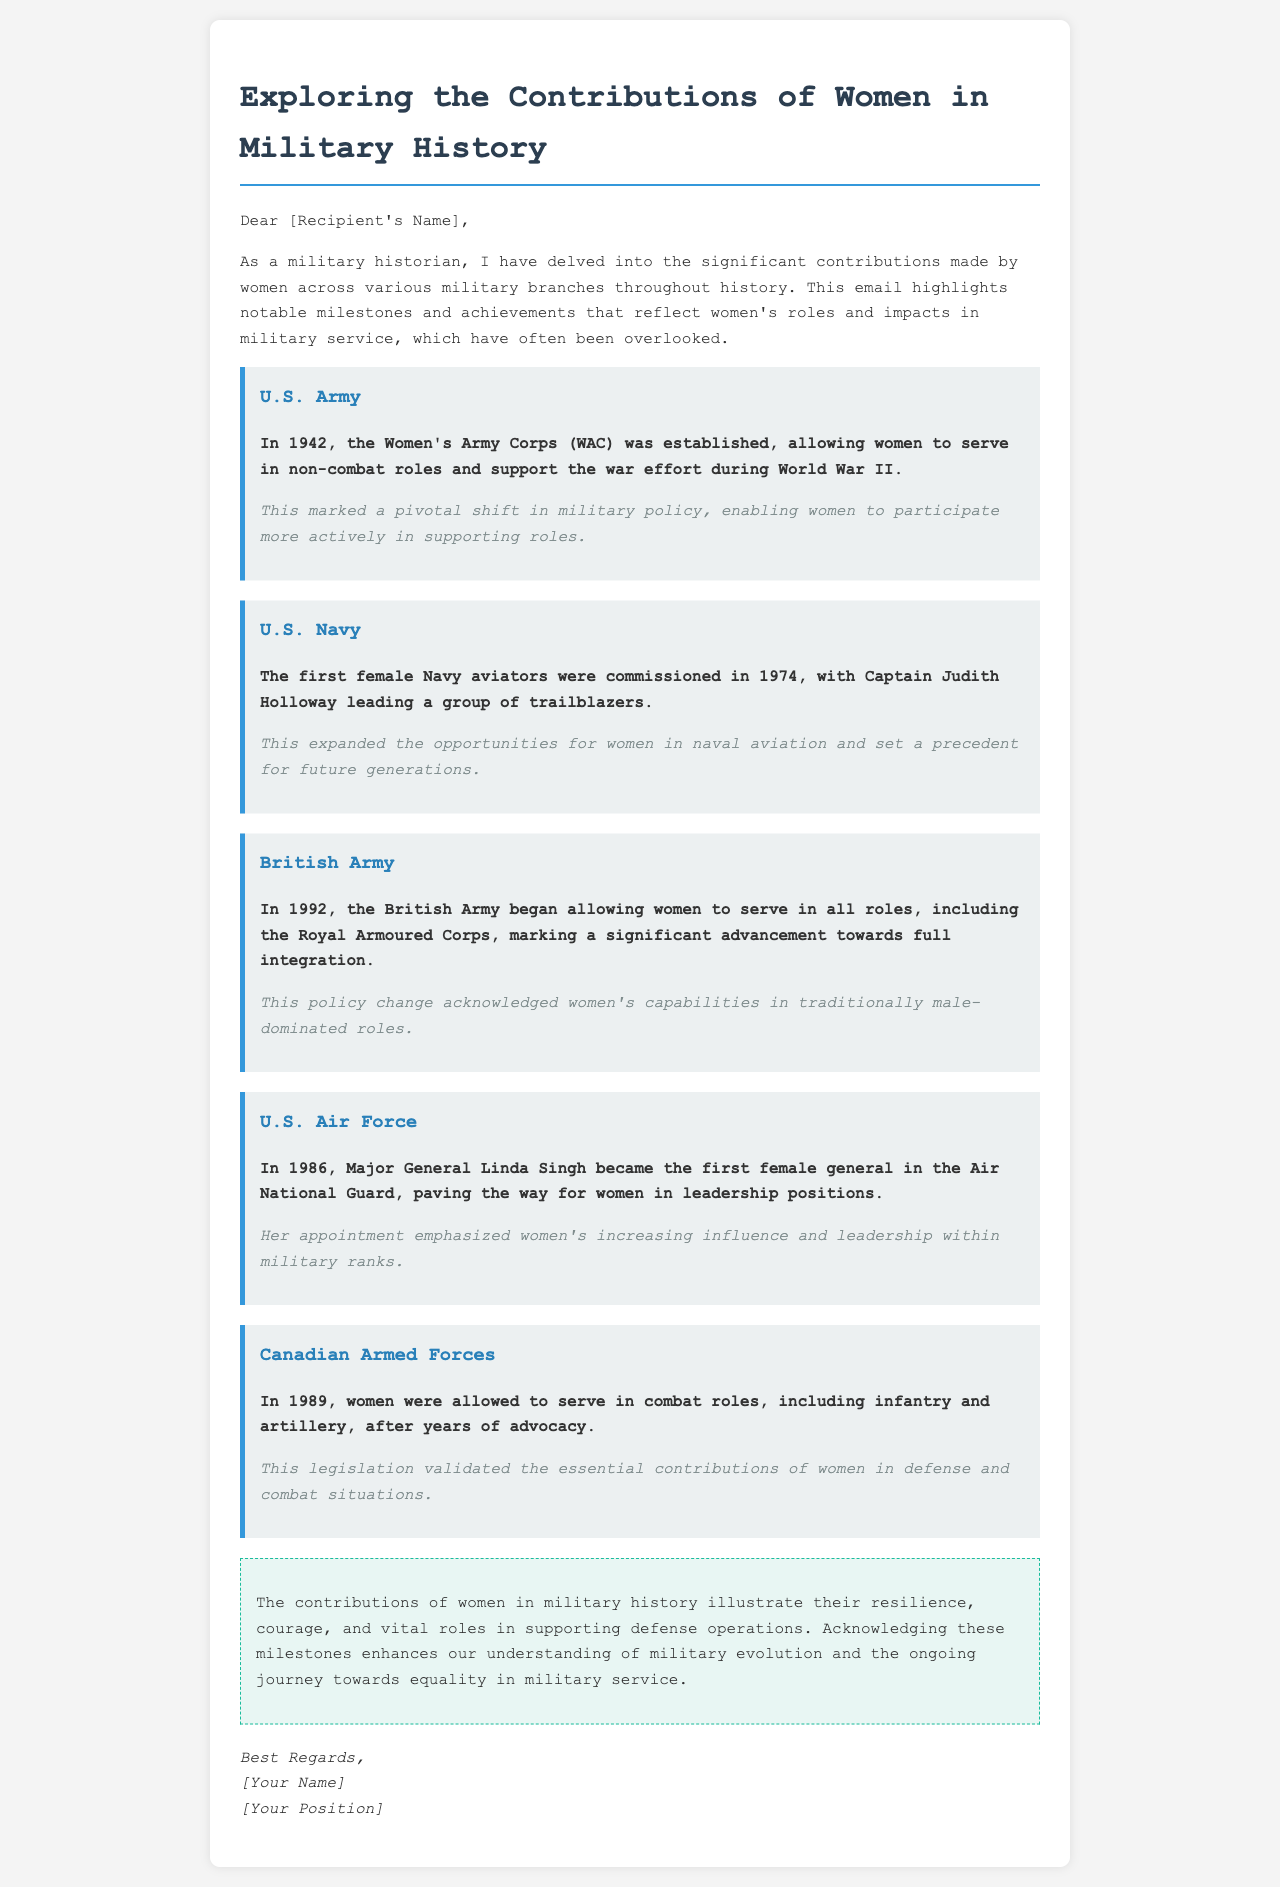what year was the Women's Army Corps established? The document states that the Women's Army Corps (WAC) was established in 1942.
Answer: 1942 who was the first female Navy aviator? According to the document, Captain Judith Holloway was the first female Navy aviator.
Answer: Captain Judith Holloway when did the British Army begin allowing women to serve in all roles? The document mentions that the British Army began allowing women to serve in all roles in 1992.
Answer: 1992 who became the first female general in the Air National Guard? The document indicates that Major General Linda Singh became the first female general in the Air National Guard in 1986.
Answer: Major General Linda Singh what significant change occurred in the Canadian Armed Forces in 1989? The document states that in 1989, women were allowed to serve in combat roles in the Canadian Armed Forces.
Answer: women were allowed to serve in combat roles what major shift did the establishment of the Women's Army Corps represent? The document explains that this marked a pivotal shift in military policy enabling women to participate more actively in supporting roles.
Answer: pivotal shift in military policy how did the 1992 British Army policy change impact women's roles? The document notes this policy change acknowledged women's capabilities in traditionally male-dominated roles.
Answer: acknowledged women's capabilities what is the tone of the conclusion in the document? The conclusion highlights the contributions of women and emphasizes resilience, courage, and essential roles in defense operations.
Answer: highlights resilience and courage 